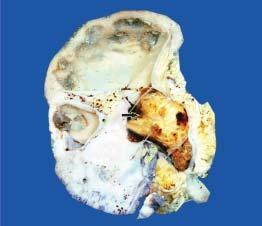what shows dilated pelvicalyceal system with atrophied and thin peripheral cortex?
Answer the question using a single word or phrase. Sectioned surface 